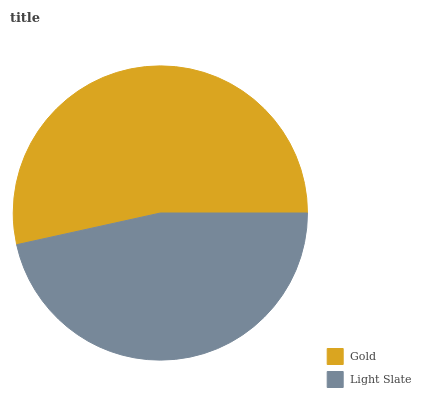Is Light Slate the minimum?
Answer yes or no. Yes. Is Gold the maximum?
Answer yes or no. Yes. Is Light Slate the maximum?
Answer yes or no. No. Is Gold greater than Light Slate?
Answer yes or no. Yes. Is Light Slate less than Gold?
Answer yes or no. Yes. Is Light Slate greater than Gold?
Answer yes or no. No. Is Gold less than Light Slate?
Answer yes or no. No. Is Gold the high median?
Answer yes or no. Yes. Is Light Slate the low median?
Answer yes or no. Yes. Is Light Slate the high median?
Answer yes or no. No. Is Gold the low median?
Answer yes or no. No. 